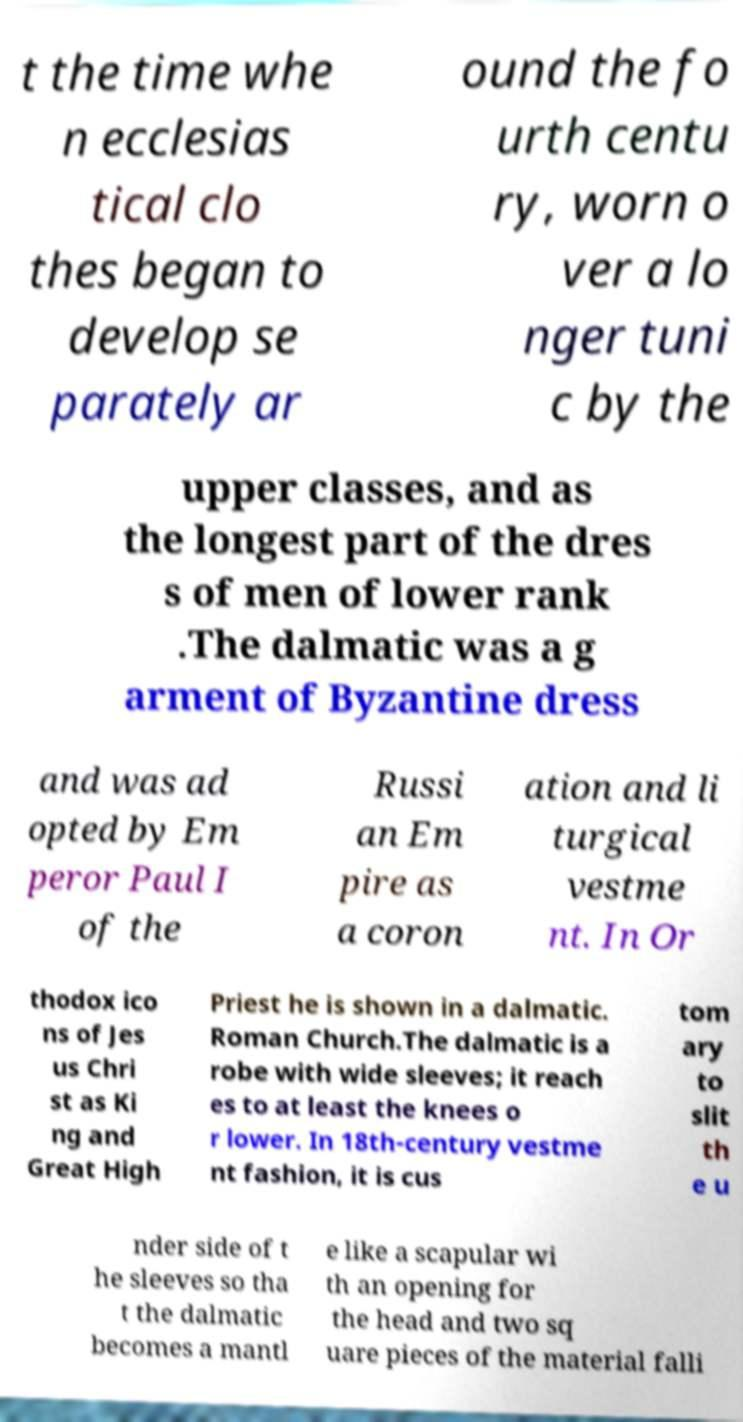Could you assist in decoding the text presented in this image and type it out clearly? t the time whe n ecclesias tical clo thes began to develop se parately ar ound the fo urth centu ry, worn o ver a lo nger tuni c by the upper classes, and as the longest part of the dres s of men of lower rank .The dalmatic was a g arment of Byzantine dress and was ad opted by Em peror Paul I of the Russi an Em pire as a coron ation and li turgical vestme nt. In Or thodox ico ns of Jes us Chri st as Ki ng and Great High Priest he is shown in a dalmatic. Roman Church.The dalmatic is a robe with wide sleeves; it reach es to at least the knees o r lower. In 18th-century vestme nt fashion, it is cus tom ary to slit th e u nder side of t he sleeves so tha t the dalmatic becomes a mantl e like a scapular wi th an opening for the head and two sq uare pieces of the material falli 